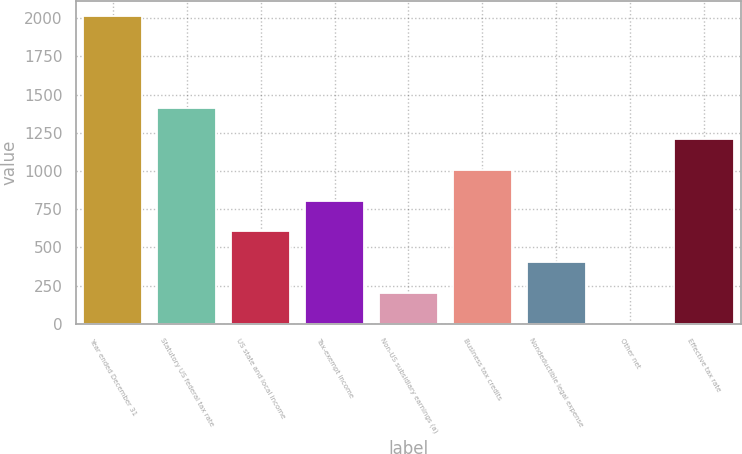Convert chart. <chart><loc_0><loc_0><loc_500><loc_500><bar_chart><fcel>Year ended December 31<fcel>Statutory US federal tax rate<fcel>US state and local income<fcel>Tax-exempt income<fcel>Non-US subsidiary earnings (a)<fcel>Business tax credits<fcel>Nondeductible legal expense<fcel>Other net<fcel>Effective tax rate<nl><fcel>2014<fcel>1410.1<fcel>604.9<fcel>806.2<fcel>202.3<fcel>1007.5<fcel>403.6<fcel>1<fcel>1208.8<nl></chart> 